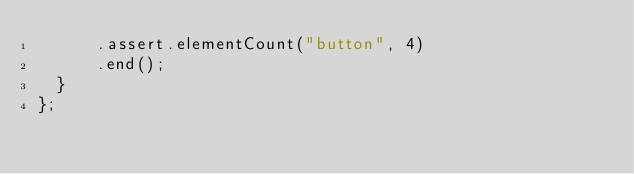Convert code to text. <code><loc_0><loc_0><loc_500><loc_500><_JavaScript_>      .assert.elementCount("button", 4)
      .end();
  }
};
</code> 